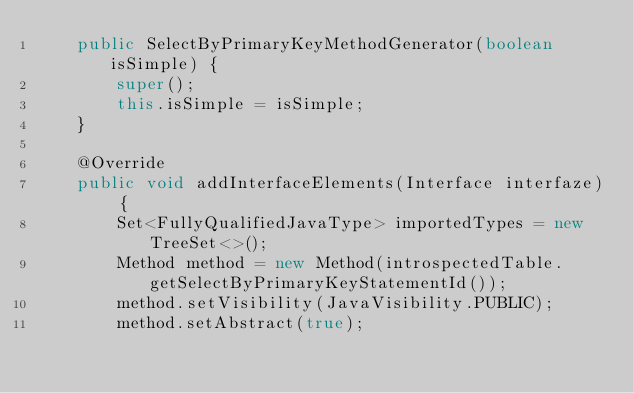Convert code to text. <code><loc_0><loc_0><loc_500><loc_500><_Java_>    public SelectByPrimaryKeyMethodGenerator(boolean isSimple) {
        super();
        this.isSimple = isSimple;
    }

    @Override
    public void addInterfaceElements(Interface interfaze) {
        Set<FullyQualifiedJavaType> importedTypes = new TreeSet<>();
        Method method = new Method(introspectedTable.getSelectByPrimaryKeyStatementId());
        method.setVisibility(JavaVisibility.PUBLIC);
        method.setAbstract(true);
</code> 